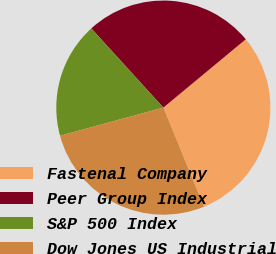<chart> <loc_0><loc_0><loc_500><loc_500><pie_chart><fcel>Fastenal Company<fcel>Peer Group Index<fcel>S&P 500 Index<fcel>Dow Jones US Industrial<nl><fcel>29.83%<fcel>25.73%<fcel>17.48%<fcel>26.96%<nl></chart> 